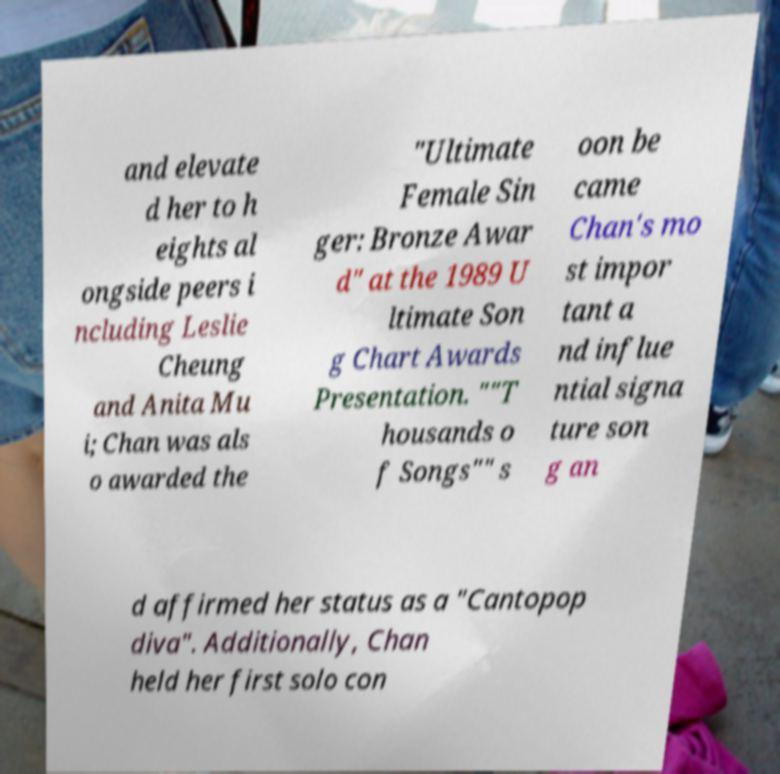Could you extract and type out the text from this image? and elevate d her to h eights al ongside peers i ncluding Leslie Cheung and Anita Mu i; Chan was als o awarded the "Ultimate Female Sin ger: Bronze Awar d" at the 1989 U ltimate Son g Chart Awards Presentation. ""T housands o f Songs"" s oon be came Chan's mo st impor tant a nd influe ntial signa ture son g an d affirmed her status as a "Cantopop diva". Additionally, Chan held her first solo con 